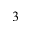<formula> <loc_0><loc_0><loc_500><loc_500>3</formula> 